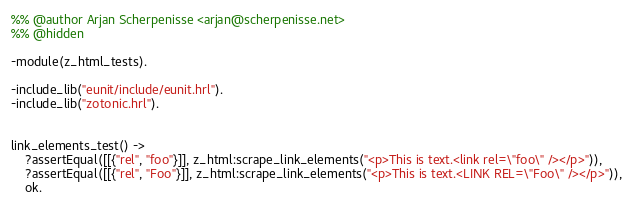Convert code to text. <code><loc_0><loc_0><loc_500><loc_500><_Erlang_>%% @author Arjan Scherpenisse <arjan@scherpenisse.net>
%% @hidden

-module(z_html_tests).

-include_lib("eunit/include/eunit.hrl").
-include_lib("zotonic.hrl").


link_elements_test() ->
    ?assertEqual([[{"rel", "foo"}]], z_html:scrape_link_elements("<p>This is text.<link rel=\"foo\" /></p>")),
    ?assertEqual([[{"rel", "Foo"}]], z_html:scrape_link_elements("<p>This is text.<LINK REL=\"Foo\" /></p>")),
    ok.
</code> 